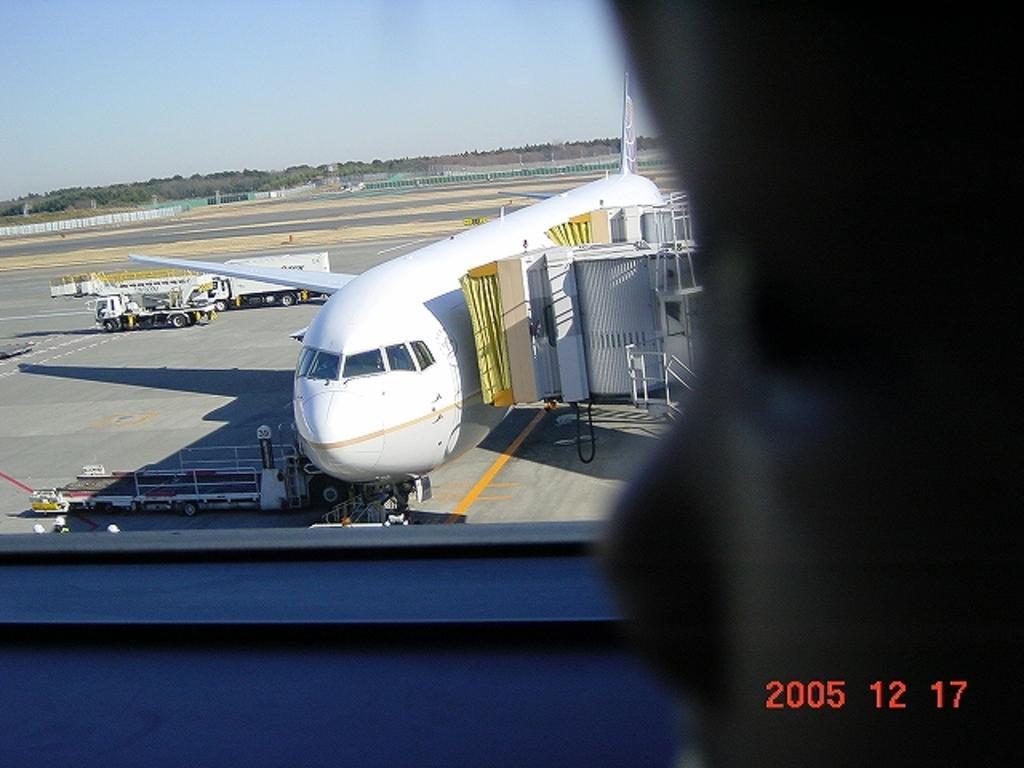How would you summarize this image in a sentence or two? Here in this picture we can see an air plane present in an airport over there and we can also see a couple of trucks present beside it over there and we can see people standing on the ground over there and in the far we can see trees and plants present over there. 